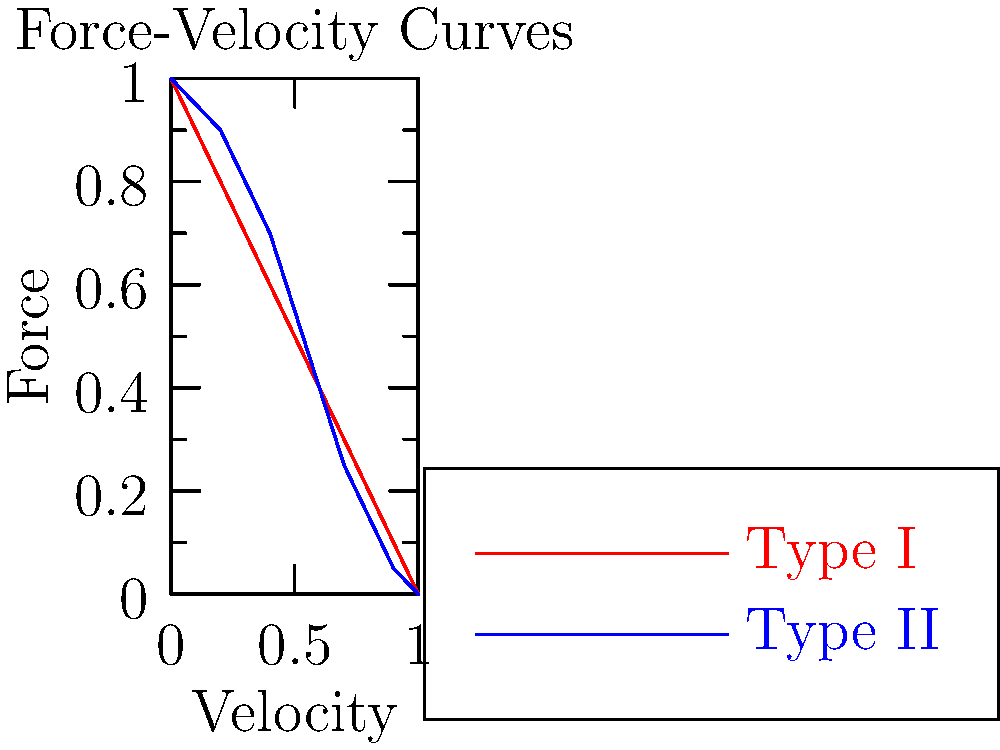Given the force-velocity curves for Type I and Type II muscle fibers shown in the graph, which type of muscle fiber is better suited for sustained, low-intensity activities? Explain your reasoning based on the characteristics of the curves. To answer this question, we need to analyze the force-velocity curves for both Type I and Type II muscle fibers:

1. Observe the curves:
   - The red curve represents Type I fibers
   - The blue curve represents Type II fibers

2. Compare the characteristics of the curves:
   - Type I (red) curve has a more gradual slope
   - Type II (blue) curve has a steeper slope

3. Interpret the meaning of the slopes:
   - A gradual slope indicates that force output decreases more slowly as velocity increases
   - A steeper slope indicates that force output decreases more rapidly as velocity increases

4. Consider the implications for muscle function:
   - Type I fibers maintain force better at higher velocities, which is advantageous for sustained activities
   - Type II fibers lose force quickly at higher velocities, which is better suited for quick, powerful movements

5. Relate to sustained, low-intensity activities:
   - These activities require maintaining force over time without rapid fatigue
   - Type I fibers, with their ability to maintain force at various velocities, are better suited for this purpose

Therefore, Type I muscle fibers are better suited for sustained, low-intensity activities due to their ability to maintain force output over a wider range of velocities, as shown by the more gradual slope of their force-velocity curve.
Answer: Type I muscle fibers 